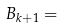Convert formula to latex. <formula><loc_0><loc_0><loc_500><loc_500>B _ { k + 1 } =</formula> 